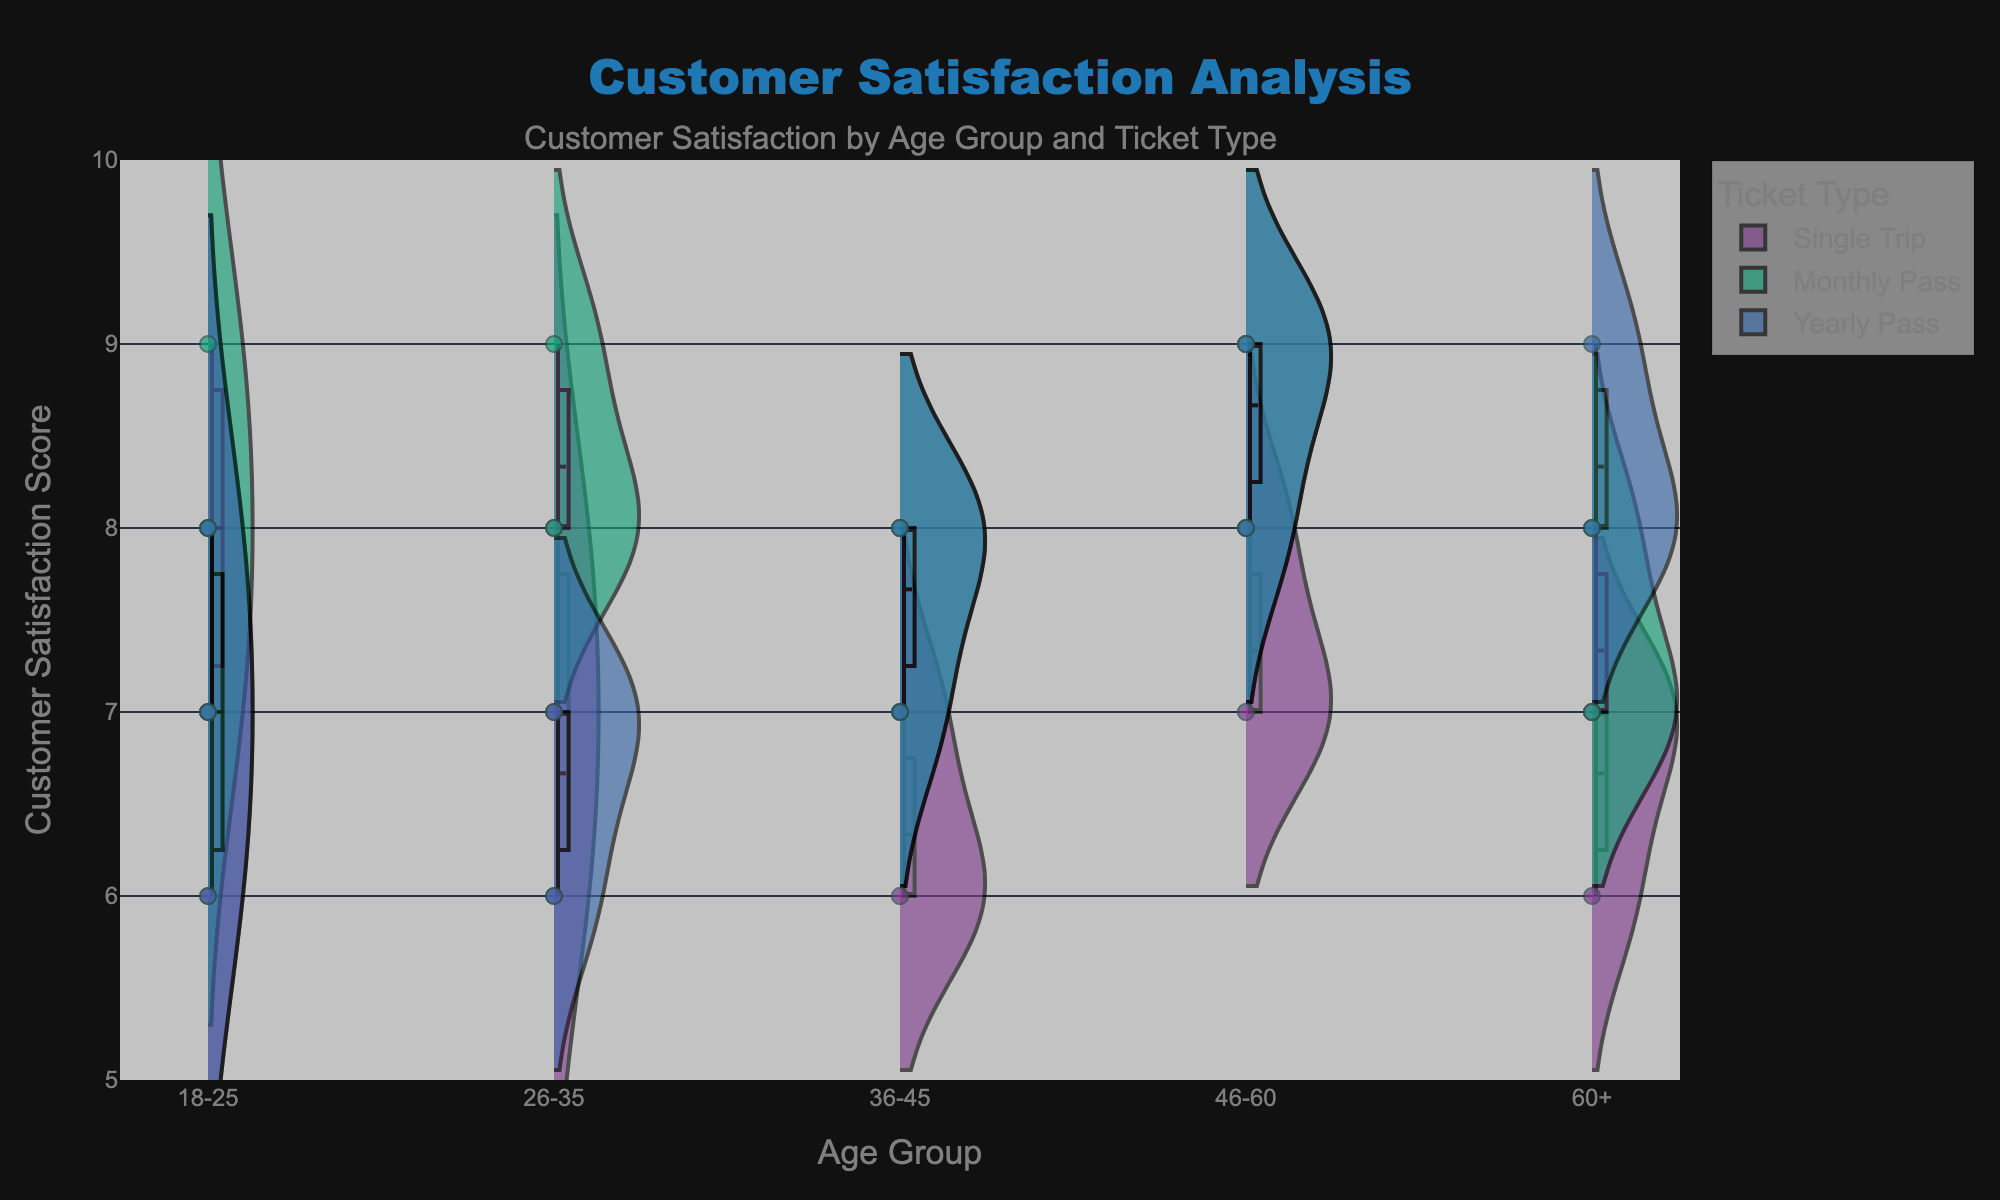What is the title of the figure? The title of the figure is displayed at the top center in a distinct font size and color
Answer: Customer Satisfaction Analysis What is the range of the y-axis? The y-axis range is given from the minimum to maximum satisfaction scores
Answer: 5 to 10 Which age group has the highest median satisfaction score for the Yearly Pass? Observe the positional markers for the Yearly Pass across the age groups and note where the median line is highest
Answer: 46-60 In the age group 36-45, which ticket type has the least variability in customer satisfaction scores? Look at the spread of the data points and the width of the violin plots for the age group 36-45 across different ticket types
Answer: Yearly Pass Which age group has the widest distribution of satisfaction scores for the Single Trip ticket type? Compare the width of the violin plots for Single Trip across all age groups and identify the one with the widest spread
Answer: 36-45 How many distinct ticket types are represented in the figure? Identify the different colors and names of the ticket types presented in the legend of the figure
Answer: 3 What is the mean satisfaction score for the 18-25 age group with a Monthly Pass? Observe the mean line within the violin plot for this specific age group and ticket type
Answer: 8 Between the age groups 26-35 and 46-60, which has higher average satisfaction scores for Single Trip tickets? Compare the position and density of the mean lines for Single Trip tickets in both age groups
Answer: 46-60 What can you infer about customer satisfaction trends for Yearly Pass holders over different age groups? Analyze the violin plots and median points for Yearly Pass across age groups to infer any trends
Answer: Generally increasing with age 